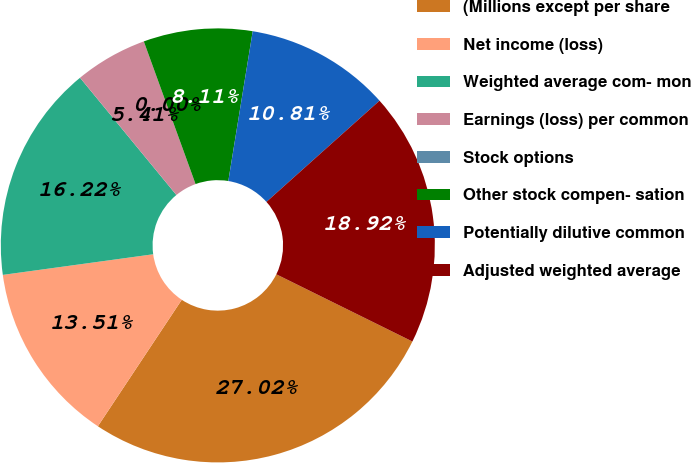Convert chart. <chart><loc_0><loc_0><loc_500><loc_500><pie_chart><fcel>(Millions except per share<fcel>Net income (loss)<fcel>Weighted average com- mon<fcel>Earnings (loss) per common<fcel>Stock options<fcel>Other stock compen- sation<fcel>Potentially dilutive common<fcel>Adjusted weighted average<nl><fcel>27.02%<fcel>13.51%<fcel>16.22%<fcel>5.41%<fcel>0.0%<fcel>8.11%<fcel>10.81%<fcel>18.92%<nl></chart> 